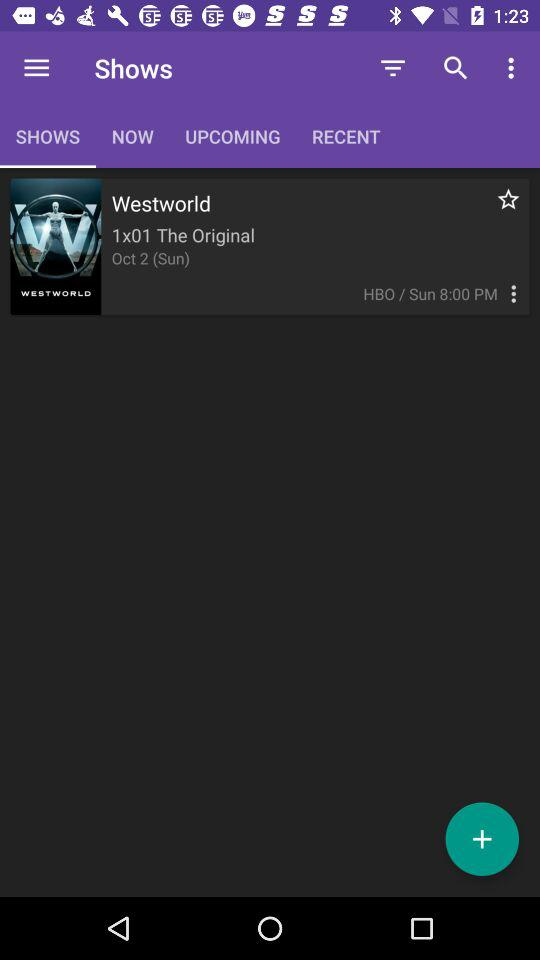What is the time of the show? The time of the show is Sunday, 8:00 PM. 